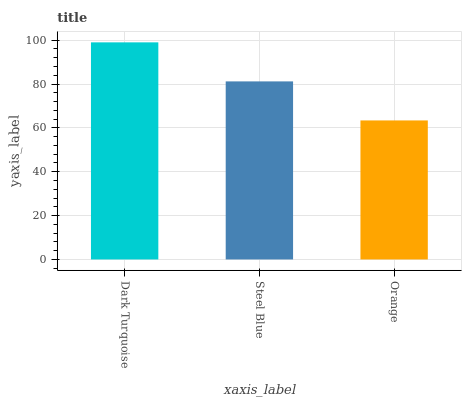Is Steel Blue the minimum?
Answer yes or no. No. Is Steel Blue the maximum?
Answer yes or no. No. Is Dark Turquoise greater than Steel Blue?
Answer yes or no. Yes. Is Steel Blue less than Dark Turquoise?
Answer yes or no. Yes. Is Steel Blue greater than Dark Turquoise?
Answer yes or no. No. Is Dark Turquoise less than Steel Blue?
Answer yes or no. No. Is Steel Blue the high median?
Answer yes or no. Yes. Is Steel Blue the low median?
Answer yes or no. Yes. Is Orange the high median?
Answer yes or no. No. Is Orange the low median?
Answer yes or no. No. 